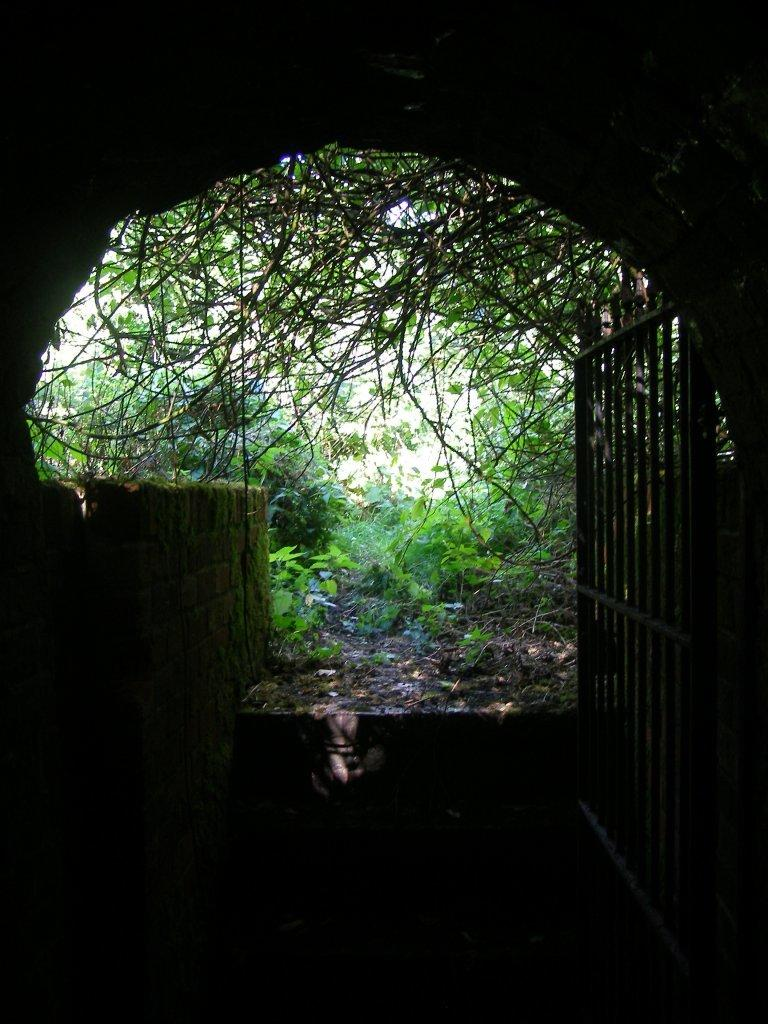What structure is located on the right side of the image? There is a gate on the right side of the image. What type of vegetation is on the ground in the image? There are plants on the ground in the image. What can be seen in the background of the image? There are trees in the background of the image. What type of passageway is visible in the image? There is a tunnel visible in the image. What type of polish is being applied to the gate in the image? There is no indication in the image that any polish is being applied to the gate. How does the society depicted in the image handle debt? There is no society depicted in the image, nor is there any mention of debt. 